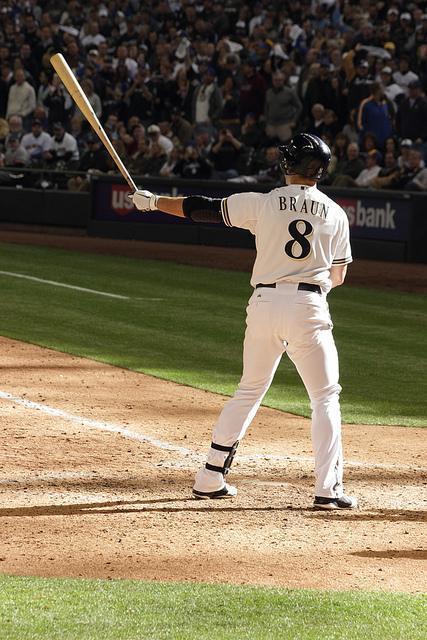How many people are there?
Give a very brief answer. 2. 